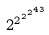Convert formula to latex. <formula><loc_0><loc_0><loc_500><loc_500>2 ^ { 2 ^ { 2 ^ { 2 ^ { 4 3 } } } }</formula> 